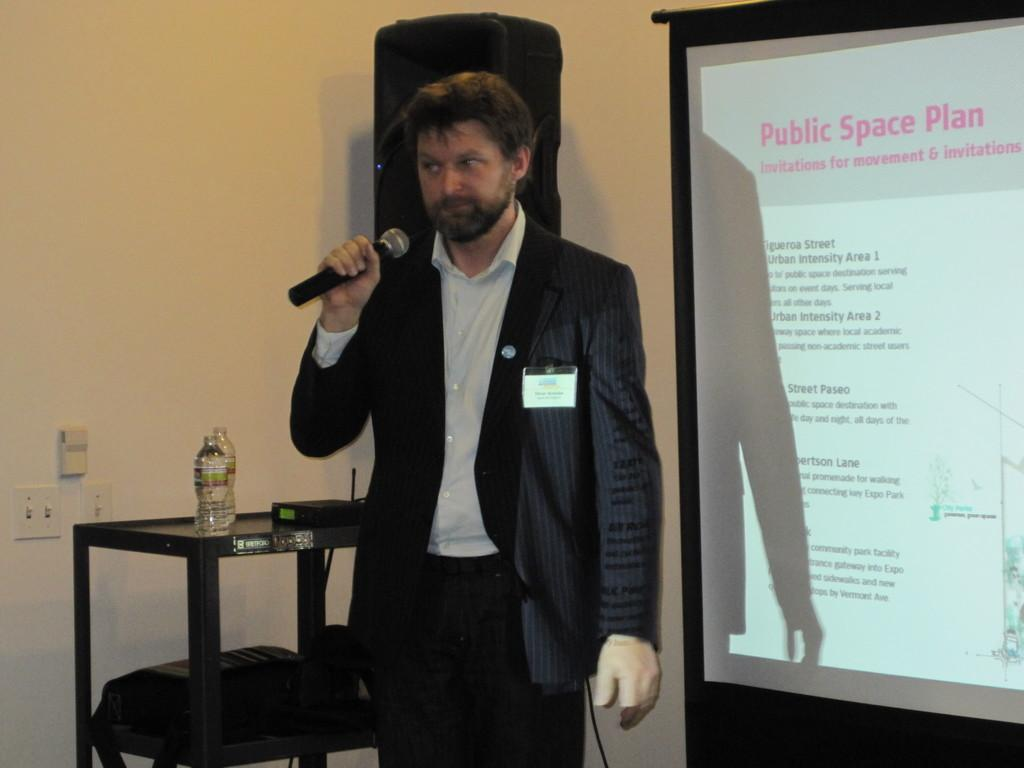What is the person in the image doing? The person is standing in front of a screen and holding a microphone. What can be seen behind the person? There is a table behind the person. What is on the table? The table contains water bottles. Where is the speaker located in the image? The speaker is attached to the wall. How many items are on the list that the person is reading from in the image? There is no list present in the image, and the person is not reading from anything. What type of owl can be seen perched on the table in the image? There is no owl present in the image; the table contains water bottles. 